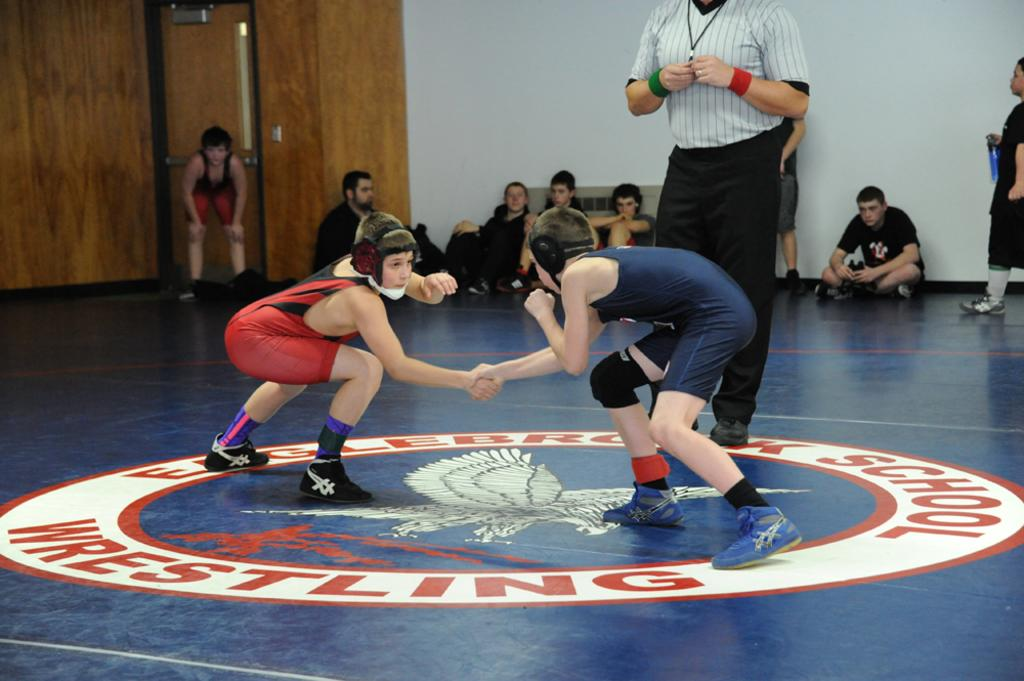<image>
Offer a succinct explanation of the picture presented. a couple of wrestlers with the word wrestling in the circle 